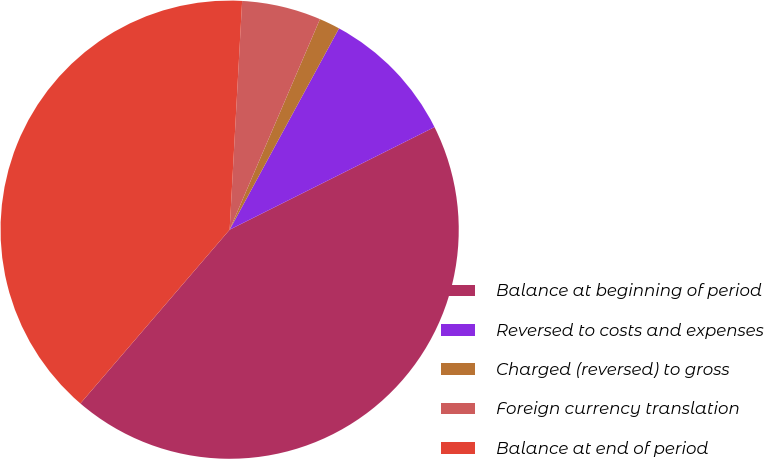Convert chart to OTSL. <chart><loc_0><loc_0><loc_500><loc_500><pie_chart><fcel>Balance at beginning of period<fcel>Reversed to costs and expenses<fcel>Charged (reversed) to gross<fcel>Foreign currency translation<fcel>Balance at end of period<nl><fcel>43.68%<fcel>9.69%<fcel>1.47%<fcel>5.58%<fcel>39.57%<nl></chart> 